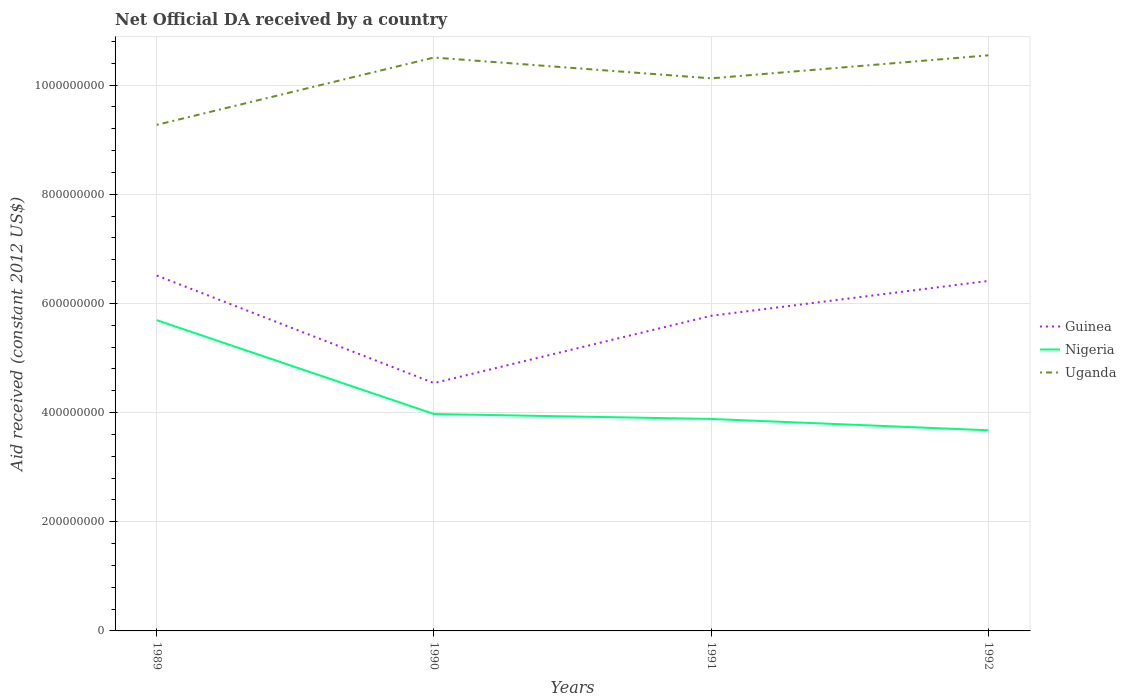How many different coloured lines are there?
Make the answer very short. 3. Does the line corresponding to Uganda intersect with the line corresponding to Nigeria?
Make the answer very short. No. Is the number of lines equal to the number of legend labels?
Give a very brief answer. Yes. Across all years, what is the maximum net official development assistance aid received in Guinea?
Your answer should be very brief. 4.54e+08. What is the total net official development assistance aid received in Uganda in the graph?
Your answer should be compact. -8.52e+07. What is the difference between the highest and the second highest net official development assistance aid received in Nigeria?
Provide a succinct answer. 2.02e+08. How many years are there in the graph?
Your response must be concise. 4. What is the difference between two consecutive major ticks on the Y-axis?
Offer a terse response. 2.00e+08. Does the graph contain any zero values?
Ensure brevity in your answer.  No. Does the graph contain grids?
Provide a succinct answer. Yes. Where does the legend appear in the graph?
Your response must be concise. Center right. How many legend labels are there?
Make the answer very short. 3. What is the title of the graph?
Offer a very short reply. Net Official DA received by a country. Does "Cabo Verde" appear as one of the legend labels in the graph?
Your answer should be compact. No. What is the label or title of the Y-axis?
Your response must be concise. Aid received (constant 2012 US$). What is the Aid received (constant 2012 US$) of Guinea in 1989?
Make the answer very short. 6.51e+08. What is the Aid received (constant 2012 US$) in Nigeria in 1989?
Your answer should be very brief. 5.69e+08. What is the Aid received (constant 2012 US$) in Uganda in 1989?
Provide a succinct answer. 9.27e+08. What is the Aid received (constant 2012 US$) in Guinea in 1990?
Make the answer very short. 4.54e+08. What is the Aid received (constant 2012 US$) in Nigeria in 1990?
Your answer should be very brief. 3.97e+08. What is the Aid received (constant 2012 US$) of Uganda in 1990?
Your answer should be compact. 1.05e+09. What is the Aid received (constant 2012 US$) of Guinea in 1991?
Your answer should be compact. 5.77e+08. What is the Aid received (constant 2012 US$) in Nigeria in 1991?
Give a very brief answer. 3.88e+08. What is the Aid received (constant 2012 US$) of Uganda in 1991?
Provide a short and direct response. 1.01e+09. What is the Aid received (constant 2012 US$) of Guinea in 1992?
Provide a short and direct response. 6.41e+08. What is the Aid received (constant 2012 US$) in Nigeria in 1992?
Give a very brief answer. 3.68e+08. What is the Aid received (constant 2012 US$) in Uganda in 1992?
Offer a terse response. 1.05e+09. Across all years, what is the maximum Aid received (constant 2012 US$) of Guinea?
Offer a very short reply. 6.51e+08. Across all years, what is the maximum Aid received (constant 2012 US$) in Nigeria?
Ensure brevity in your answer.  5.69e+08. Across all years, what is the maximum Aid received (constant 2012 US$) of Uganda?
Offer a very short reply. 1.05e+09. Across all years, what is the minimum Aid received (constant 2012 US$) in Guinea?
Offer a very short reply. 4.54e+08. Across all years, what is the minimum Aid received (constant 2012 US$) in Nigeria?
Offer a terse response. 3.68e+08. Across all years, what is the minimum Aid received (constant 2012 US$) in Uganda?
Your answer should be compact. 9.27e+08. What is the total Aid received (constant 2012 US$) of Guinea in the graph?
Make the answer very short. 2.32e+09. What is the total Aid received (constant 2012 US$) of Nigeria in the graph?
Your answer should be very brief. 1.72e+09. What is the total Aid received (constant 2012 US$) of Uganda in the graph?
Offer a very short reply. 4.04e+09. What is the difference between the Aid received (constant 2012 US$) in Guinea in 1989 and that in 1990?
Ensure brevity in your answer.  1.97e+08. What is the difference between the Aid received (constant 2012 US$) in Nigeria in 1989 and that in 1990?
Ensure brevity in your answer.  1.72e+08. What is the difference between the Aid received (constant 2012 US$) of Uganda in 1989 and that in 1990?
Provide a short and direct response. -1.23e+08. What is the difference between the Aid received (constant 2012 US$) of Guinea in 1989 and that in 1991?
Provide a succinct answer. 7.37e+07. What is the difference between the Aid received (constant 2012 US$) in Nigeria in 1989 and that in 1991?
Your answer should be compact. 1.81e+08. What is the difference between the Aid received (constant 2012 US$) in Uganda in 1989 and that in 1991?
Give a very brief answer. -8.52e+07. What is the difference between the Aid received (constant 2012 US$) in Guinea in 1989 and that in 1992?
Offer a very short reply. 9.90e+06. What is the difference between the Aid received (constant 2012 US$) in Nigeria in 1989 and that in 1992?
Ensure brevity in your answer.  2.02e+08. What is the difference between the Aid received (constant 2012 US$) of Uganda in 1989 and that in 1992?
Your response must be concise. -1.27e+08. What is the difference between the Aid received (constant 2012 US$) of Guinea in 1990 and that in 1991?
Provide a succinct answer. -1.23e+08. What is the difference between the Aid received (constant 2012 US$) in Nigeria in 1990 and that in 1991?
Ensure brevity in your answer.  9.02e+06. What is the difference between the Aid received (constant 2012 US$) of Uganda in 1990 and that in 1991?
Your answer should be very brief. 3.81e+07. What is the difference between the Aid received (constant 2012 US$) of Guinea in 1990 and that in 1992?
Ensure brevity in your answer.  -1.87e+08. What is the difference between the Aid received (constant 2012 US$) in Nigeria in 1990 and that in 1992?
Offer a very short reply. 2.98e+07. What is the difference between the Aid received (constant 2012 US$) in Uganda in 1990 and that in 1992?
Make the answer very short. -4.04e+06. What is the difference between the Aid received (constant 2012 US$) in Guinea in 1991 and that in 1992?
Ensure brevity in your answer.  -6.38e+07. What is the difference between the Aid received (constant 2012 US$) of Nigeria in 1991 and that in 1992?
Offer a very short reply. 2.08e+07. What is the difference between the Aid received (constant 2012 US$) in Uganda in 1991 and that in 1992?
Ensure brevity in your answer.  -4.22e+07. What is the difference between the Aid received (constant 2012 US$) in Guinea in 1989 and the Aid received (constant 2012 US$) in Nigeria in 1990?
Make the answer very short. 2.54e+08. What is the difference between the Aid received (constant 2012 US$) in Guinea in 1989 and the Aid received (constant 2012 US$) in Uganda in 1990?
Your answer should be compact. -3.99e+08. What is the difference between the Aid received (constant 2012 US$) of Nigeria in 1989 and the Aid received (constant 2012 US$) of Uganda in 1990?
Your answer should be very brief. -4.81e+08. What is the difference between the Aid received (constant 2012 US$) in Guinea in 1989 and the Aid received (constant 2012 US$) in Nigeria in 1991?
Offer a very short reply. 2.63e+08. What is the difference between the Aid received (constant 2012 US$) of Guinea in 1989 and the Aid received (constant 2012 US$) of Uganda in 1991?
Provide a succinct answer. -3.61e+08. What is the difference between the Aid received (constant 2012 US$) of Nigeria in 1989 and the Aid received (constant 2012 US$) of Uganda in 1991?
Offer a very short reply. -4.43e+08. What is the difference between the Aid received (constant 2012 US$) of Guinea in 1989 and the Aid received (constant 2012 US$) of Nigeria in 1992?
Make the answer very short. 2.84e+08. What is the difference between the Aid received (constant 2012 US$) of Guinea in 1989 and the Aid received (constant 2012 US$) of Uganda in 1992?
Your answer should be compact. -4.03e+08. What is the difference between the Aid received (constant 2012 US$) in Nigeria in 1989 and the Aid received (constant 2012 US$) in Uganda in 1992?
Your answer should be compact. -4.85e+08. What is the difference between the Aid received (constant 2012 US$) of Guinea in 1990 and the Aid received (constant 2012 US$) of Nigeria in 1991?
Your answer should be compact. 6.57e+07. What is the difference between the Aid received (constant 2012 US$) in Guinea in 1990 and the Aid received (constant 2012 US$) in Uganda in 1991?
Ensure brevity in your answer.  -5.58e+08. What is the difference between the Aid received (constant 2012 US$) in Nigeria in 1990 and the Aid received (constant 2012 US$) in Uganda in 1991?
Give a very brief answer. -6.15e+08. What is the difference between the Aid received (constant 2012 US$) in Guinea in 1990 and the Aid received (constant 2012 US$) in Nigeria in 1992?
Your answer should be very brief. 8.65e+07. What is the difference between the Aid received (constant 2012 US$) in Guinea in 1990 and the Aid received (constant 2012 US$) in Uganda in 1992?
Offer a terse response. -6.00e+08. What is the difference between the Aid received (constant 2012 US$) of Nigeria in 1990 and the Aid received (constant 2012 US$) of Uganda in 1992?
Keep it short and to the point. -6.57e+08. What is the difference between the Aid received (constant 2012 US$) in Guinea in 1991 and the Aid received (constant 2012 US$) in Nigeria in 1992?
Provide a succinct answer. 2.10e+08. What is the difference between the Aid received (constant 2012 US$) in Guinea in 1991 and the Aid received (constant 2012 US$) in Uganda in 1992?
Give a very brief answer. -4.77e+08. What is the difference between the Aid received (constant 2012 US$) in Nigeria in 1991 and the Aid received (constant 2012 US$) in Uganda in 1992?
Your answer should be compact. -6.66e+08. What is the average Aid received (constant 2012 US$) in Guinea per year?
Make the answer very short. 5.81e+08. What is the average Aid received (constant 2012 US$) of Nigeria per year?
Provide a short and direct response. 4.31e+08. What is the average Aid received (constant 2012 US$) of Uganda per year?
Offer a terse response. 1.01e+09. In the year 1989, what is the difference between the Aid received (constant 2012 US$) of Guinea and Aid received (constant 2012 US$) of Nigeria?
Offer a terse response. 8.18e+07. In the year 1989, what is the difference between the Aid received (constant 2012 US$) of Guinea and Aid received (constant 2012 US$) of Uganda?
Keep it short and to the point. -2.76e+08. In the year 1989, what is the difference between the Aid received (constant 2012 US$) of Nigeria and Aid received (constant 2012 US$) of Uganda?
Your answer should be very brief. -3.58e+08. In the year 1990, what is the difference between the Aid received (constant 2012 US$) of Guinea and Aid received (constant 2012 US$) of Nigeria?
Your answer should be very brief. 5.67e+07. In the year 1990, what is the difference between the Aid received (constant 2012 US$) in Guinea and Aid received (constant 2012 US$) in Uganda?
Offer a terse response. -5.96e+08. In the year 1990, what is the difference between the Aid received (constant 2012 US$) of Nigeria and Aid received (constant 2012 US$) of Uganda?
Keep it short and to the point. -6.53e+08. In the year 1991, what is the difference between the Aid received (constant 2012 US$) in Guinea and Aid received (constant 2012 US$) in Nigeria?
Provide a succinct answer. 1.89e+08. In the year 1991, what is the difference between the Aid received (constant 2012 US$) of Guinea and Aid received (constant 2012 US$) of Uganda?
Offer a terse response. -4.35e+08. In the year 1991, what is the difference between the Aid received (constant 2012 US$) of Nigeria and Aid received (constant 2012 US$) of Uganda?
Offer a terse response. -6.24e+08. In the year 1992, what is the difference between the Aid received (constant 2012 US$) of Guinea and Aid received (constant 2012 US$) of Nigeria?
Your answer should be compact. 2.74e+08. In the year 1992, what is the difference between the Aid received (constant 2012 US$) in Guinea and Aid received (constant 2012 US$) in Uganda?
Your answer should be compact. -4.13e+08. In the year 1992, what is the difference between the Aid received (constant 2012 US$) in Nigeria and Aid received (constant 2012 US$) in Uganda?
Your answer should be compact. -6.87e+08. What is the ratio of the Aid received (constant 2012 US$) of Guinea in 1989 to that in 1990?
Offer a very short reply. 1.43. What is the ratio of the Aid received (constant 2012 US$) of Nigeria in 1989 to that in 1990?
Offer a terse response. 1.43. What is the ratio of the Aid received (constant 2012 US$) of Uganda in 1989 to that in 1990?
Make the answer very short. 0.88. What is the ratio of the Aid received (constant 2012 US$) in Guinea in 1989 to that in 1991?
Offer a very short reply. 1.13. What is the ratio of the Aid received (constant 2012 US$) in Nigeria in 1989 to that in 1991?
Keep it short and to the point. 1.47. What is the ratio of the Aid received (constant 2012 US$) of Uganda in 1989 to that in 1991?
Keep it short and to the point. 0.92. What is the ratio of the Aid received (constant 2012 US$) of Guinea in 1989 to that in 1992?
Keep it short and to the point. 1.02. What is the ratio of the Aid received (constant 2012 US$) in Nigeria in 1989 to that in 1992?
Keep it short and to the point. 1.55. What is the ratio of the Aid received (constant 2012 US$) in Uganda in 1989 to that in 1992?
Keep it short and to the point. 0.88. What is the ratio of the Aid received (constant 2012 US$) of Guinea in 1990 to that in 1991?
Provide a succinct answer. 0.79. What is the ratio of the Aid received (constant 2012 US$) of Nigeria in 1990 to that in 1991?
Make the answer very short. 1.02. What is the ratio of the Aid received (constant 2012 US$) in Uganda in 1990 to that in 1991?
Ensure brevity in your answer.  1.04. What is the ratio of the Aid received (constant 2012 US$) in Guinea in 1990 to that in 1992?
Keep it short and to the point. 0.71. What is the ratio of the Aid received (constant 2012 US$) of Nigeria in 1990 to that in 1992?
Offer a very short reply. 1.08. What is the ratio of the Aid received (constant 2012 US$) of Guinea in 1991 to that in 1992?
Give a very brief answer. 0.9. What is the ratio of the Aid received (constant 2012 US$) of Nigeria in 1991 to that in 1992?
Your answer should be compact. 1.06. What is the ratio of the Aid received (constant 2012 US$) of Uganda in 1991 to that in 1992?
Give a very brief answer. 0.96. What is the difference between the highest and the second highest Aid received (constant 2012 US$) of Guinea?
Your answer should be very brief. 9.90e+06. What is the difference between the highest and the second highest Aid received (constant 2012 US$) in Nigeria?
Ensure brevity in your answer.  1.72e+08. What is the difference between the highest and the second highest Aid received (constant 2012 US$) in Uganda?
Your answer should be very brief. 4.04e+06. What is the difference between the highest and the lowest Aid received (constant 2012 US$) of Guinea?
Give a very brief answer. 1.97e+08. What is the difference between the highest and the lowest Aid received (constant 2012 US$) in Nigeria?
Keep it short and to the point. 2.02e+08. What is the difference between the highest and the lowest Aid received (constant 2012 US$) of Uganda?
Offer a very short reply. 1.27e+08. 